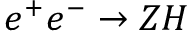<formula> <loc_0><loc_0><loc_500><loc_500>e ^ { + } e ^ { - } \rightarrow Z H</formula> 